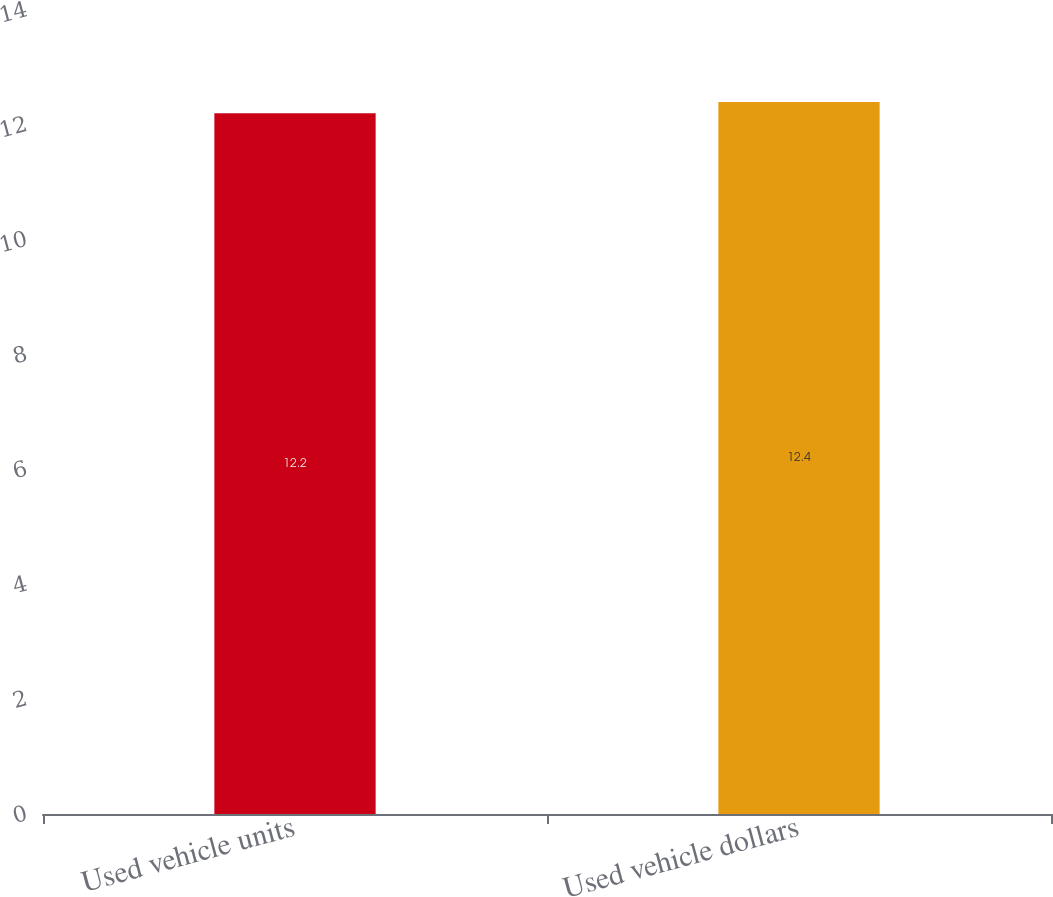Convert chart to OTSL. <chart><loc_0><loc_0><loc_500><loc_500><bar_chart><fcel>Used vehicle units<fcel>Used vehicle dollars<nl><fcel>12.2<fcel>12.4<nl></chart> 